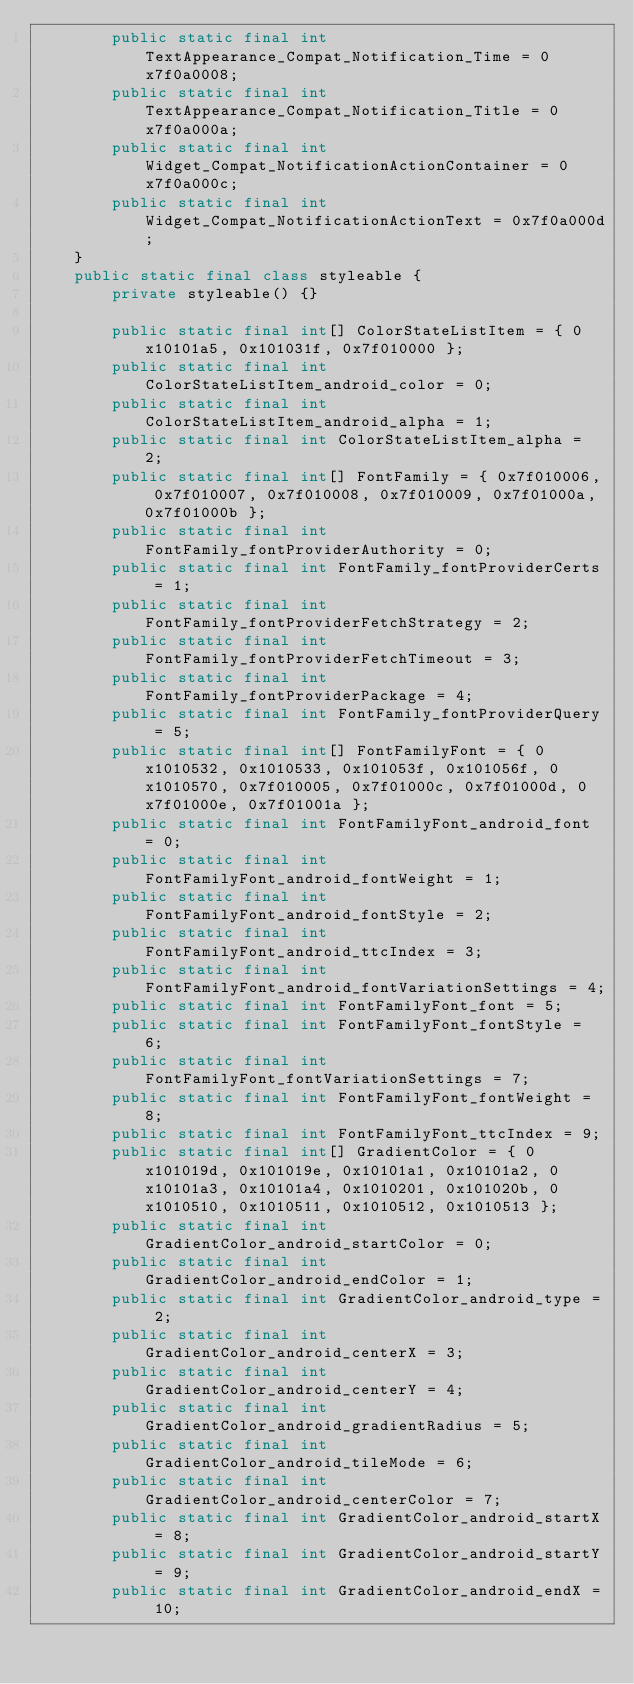<code> <loc_0><loc_0><loc_500><loc_500><_Java_>        public static final int TextAppearance_Compat_Notification_Time = 0x7f0a0008;
        public static final int TextAppearance_Compat_Notification_Title = 0x7f0a000a;
        public static final int Widget_Compat_NotificationActionContainer = 0x7f0a000c;
        public static final int Widget_Compat_NotificationActionText = 0x7f0a000d;
    }
    public static final class styleable {
        private styleable() {}

        public static final int[] ColorStateListItem = { 0x10101a5, 0x101031f, 0x7f010000 };
        public static final int ColorStateListItem_android_color = 0;
        public static final int ColorStateListItem_android_alpha = 1;
        public static final int ColorStateListItem_alpha = 2;
        public static final int[] FontFamily = { 0x7f010006, 0x7f010007, 0x7f010008, 0x7f010009, 0x7f01000a, 0x7f01000b };
        public static final int FontFamily_fontProviderAuthority = 0;
        public static final int FontFamily_fontProviderCerts = 1;
        public static final int FontFamily_fontProviderFetchStrategy = 2;
        public static final int FontFamily_fontProviderFetchTimeout = 3;
        public static final int FontFamily_fontProviderPackage = 4;
        public static final int FontFamily_fontProviderQuery = 5;
        public static final int[] FontFamilyFont = { 0x1010532, 0x1010533, 0x101053f, 0x101056f, 0x1010570, 0x7f010005, 0x7f01000c, 0x7f01000d, 0x7f01000e, 0x7f01001a };
        public static final int FontFamilyFont_android_font = 0;
        public static final int FontFamilyFont_android_fontWeight = 1;
        public static final int FontFamilyFont_android_fontStyle = 2;
        public static final int FontFamilyFont_android_ttcIndex = 3;
        public static final int FontFamilyFont_android_fontVariationSettings = 4;
        public static final int FontFamilyFont_font = 5;
        public static final int FontFamilyFont_fontStyle = 6;
        public static final int FontFamilyFont_fontVariationSettings = 7;
        public static final int FontFamilyFont_fontWeight = 8;
        public static final int FontFamilyFont_ttcIndex = 9;
        public static final int[] GradientColor = { 0x101019d, 0x101019e, 0x10101a1, 0x10101a2, 0x10101a3, 0x10101a4, 0x1010201, 0x101020b, 0x1010510, 0x1010511, 0x1010512, 0x1010513 };
        public static final int GradientColor_android_startColor = 0;
        public static final int GradientColor_android_endColor = 1;
        public static final int GradientColor_android_type = 2;
        public static final int GradientColor_android_centerX = 3;
        public static final int GradientColor_android_centerY = 4;
        public static final int GradientColor_android_gradientRadius = 5;
        public static final int GradientColor_android_tileMode = 6;
        public static final int GradientColor_android_centerColor = 7;
        public static final int GradientColor_android_startX = 8;
        public static final int GradientColor_android_startY = 9;
        public static final int GradientColor_android_endX = 10;</code> 